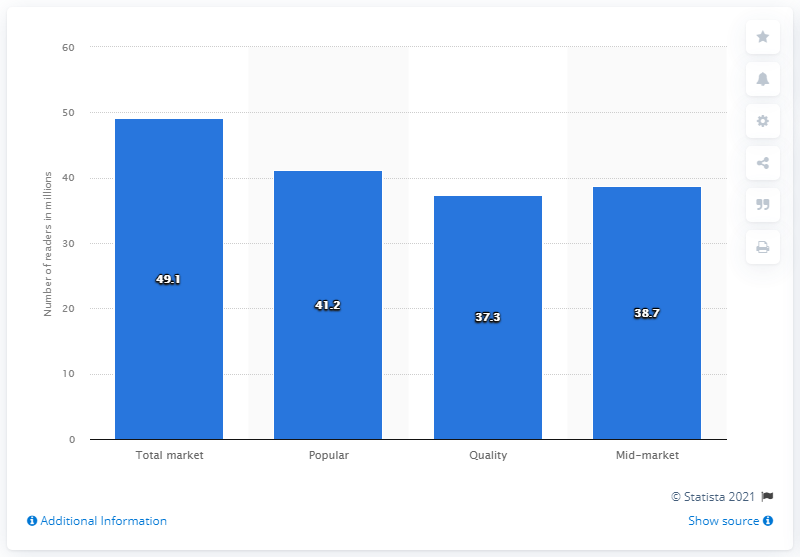Mention a couple of crucial points in this snapshot. According to data from the UK, during the period of April 2019 to March 2020, an estimated 49.1% of adults read newspaper brands on a monthly basis. During the period of April 2019 and March 2020, the most read mid-market publications in the UK had 38.7 readers. 